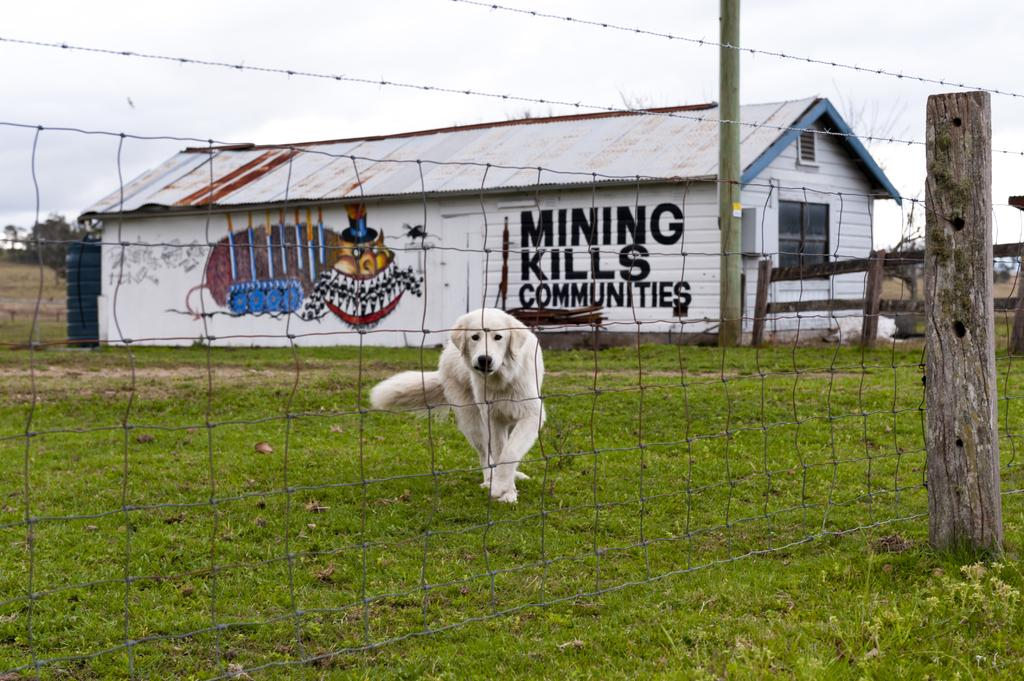What is the main structure visible in the image? There is a fencing in the image. What is located behind the fencing? There is a dog on the grass surface behind the fencing. What can be seen in the background behind the dog? There is a house visible behind the dog. What type of rhythm can be heard coming from the sea in the image? There is no sea present in the image, so it's not possible to determine what, if any, rhythm might be heard. 